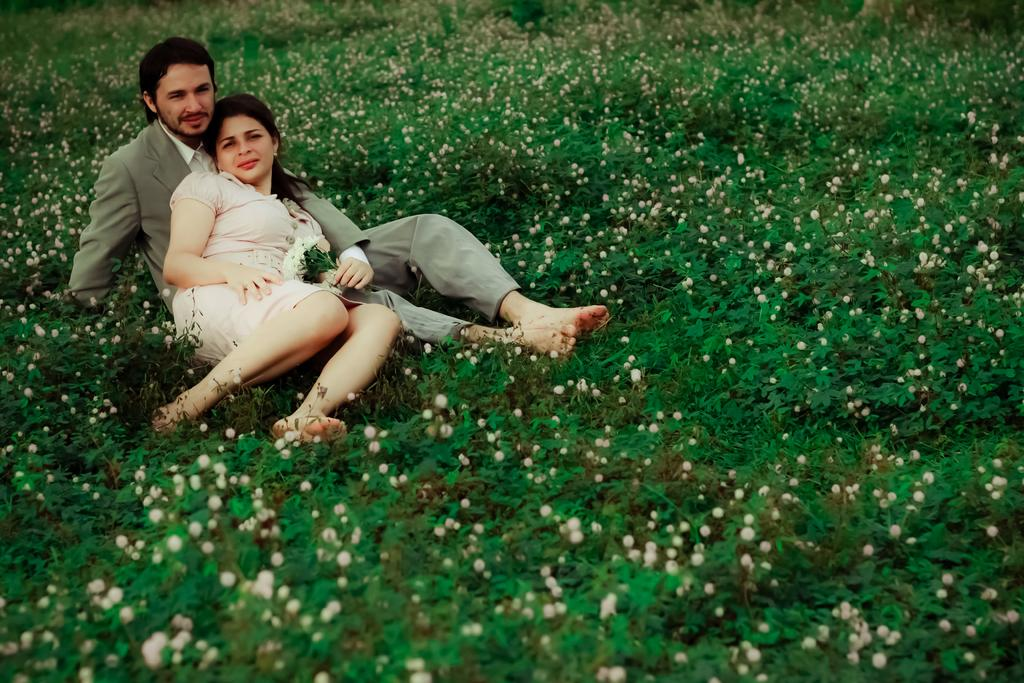Who is present in the image? There is a couple in the image. What are the couple doing in the image? The couple is sitting and posing for a photo. Can you describe the man in the image? The man is holding flowers in the image. What else can be seen in the image besides the couple? There are plants with flowers in the image. What type of substance is the man using to create the flowers in the image? There is no indication in the image that the man is creating the flowers, and there is no substance involved in the flowers' presence. 